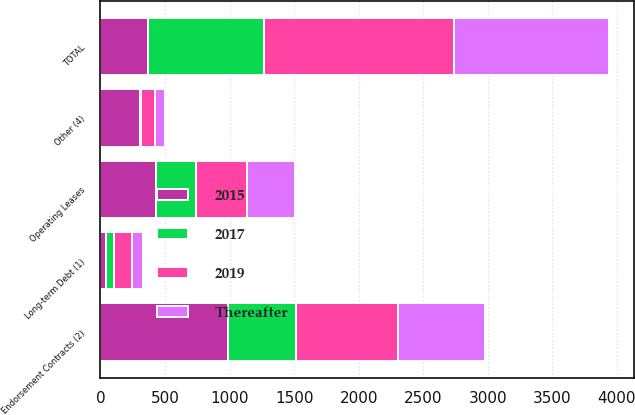Convert chart. <chart><loc_0><loc_0><loc_500><loc_500><stacked_bar_chart><ecel><fcel>Operating Leases<fcel>Long-term Debt (1)<fcel>Endorsement Contracts (2)<fcel>Other (4)<fcel>TOTAL<nl><fcel>2015<fcel>427<fcel>46<fcel>991<fcel>309<fcel>366<nl><fcel>2019<fcel>399<fcel>145<fcel>787<fcel>108<fcel>1474<nl><fcel>Thereafter<fcel>366<fcel>79<fcel>672<fcel>78<fcel>1196<nl><fcel>2017<fcel>311<fcel>56<fcel>524<fcel>7<fcel>899<nl></chart> 